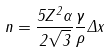Convert formula to latex. <formula><loc_0><loc_0><loc_500><loc_500>n = \frac { 5 Z ^ { 2 } \alpha } { 2 \sqrt { 3 } } \frac { \gamma } { \rho } \Delta x</formula> 